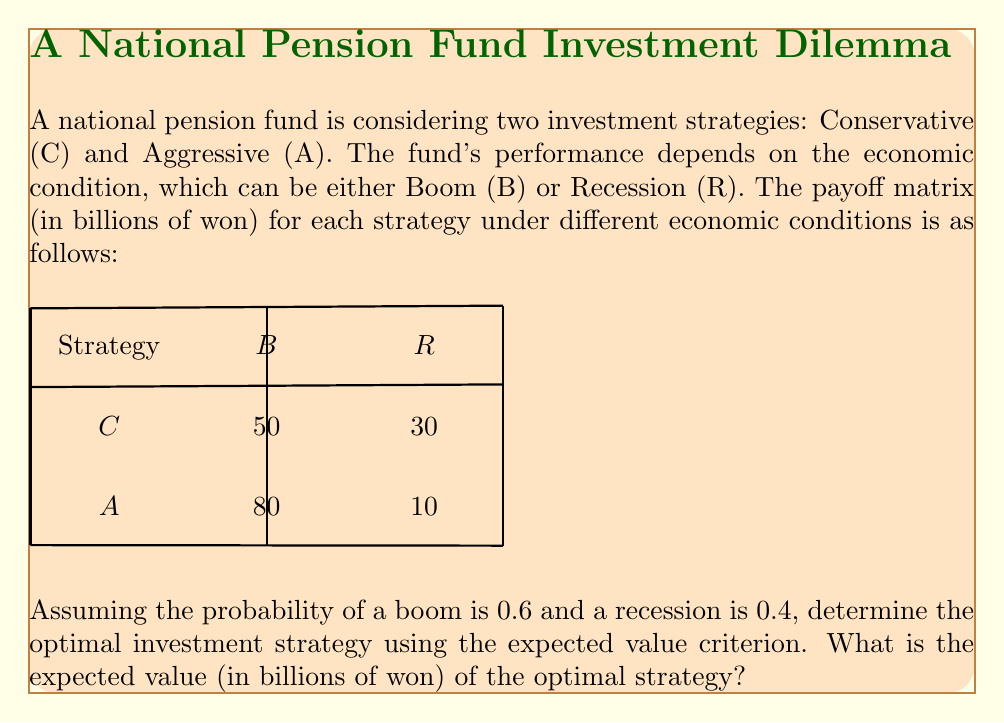Can you answer this question? To solve this problem, we'll use the expected value criterion from game theory. Here's a step-by-step approach:

1) First, let's calculate the expected value for each strategy:

   For Conservative (C):
   $$ E(C) = 0.6 \times 50 + 0.4 \times 30 = 42 $$

   For Aggressive (A):
   $$ E(A) = 0.6 \times 80 + 0.4 \times 10 = 52 $$

2) The expected value criterion suggests choosing the strategy with the highest expected value.

3) Comparing the expected values:
   $$ E(A) > E(C) $$ 
   $$ 52 > 42 $$

4) Therefore, the Aggressive strategy (A) has a higher expected value and is the optimal choice under these conditions.

5) The expected value of the optimal strategy (Aggressive) is 52 billion won.
Answer: 52 billion won 